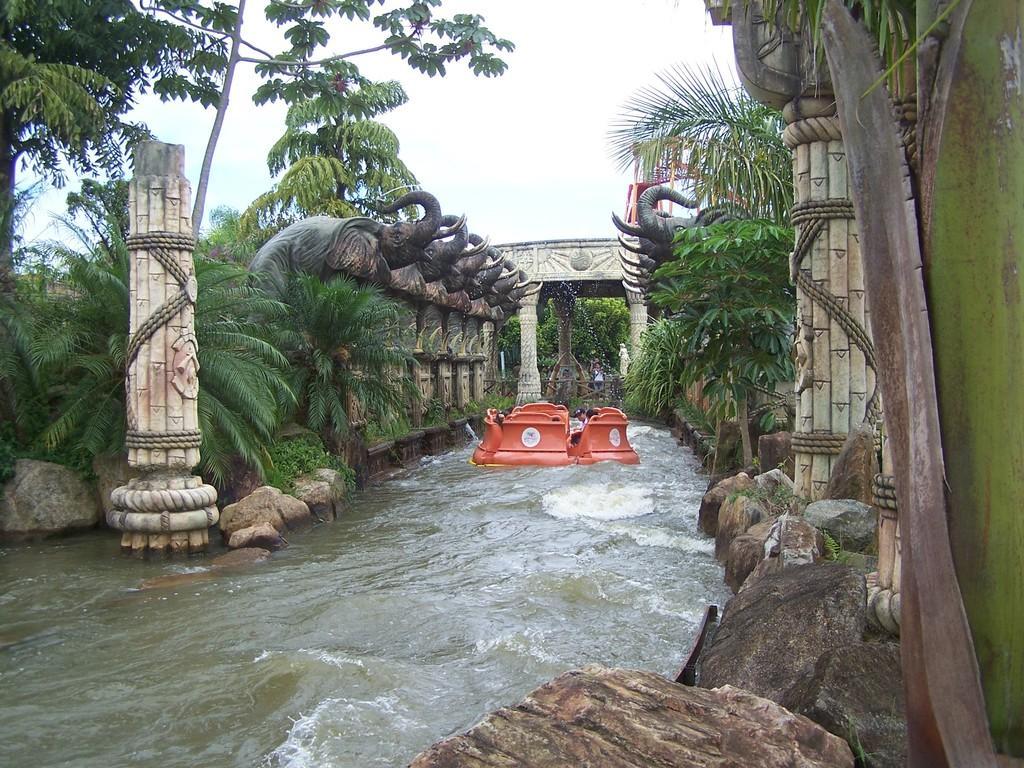How would you summarize this image in a sentence or two? In this image I can see red color object on the water. Here I can see statues of elephants, trees, plants, pillars and rocks. In the background I can see the sky. 